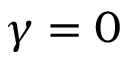<formula> <loc_0><loc_0><loc_500><loc_500>\gamma = 0</formula> 